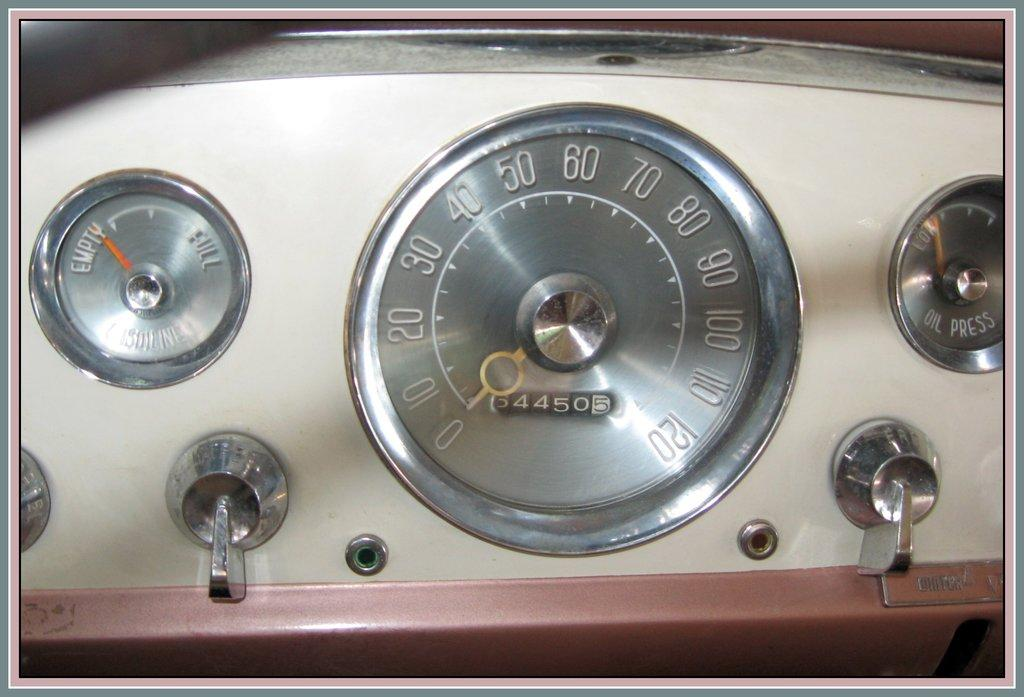What device is visible in the image? There is a speedometer in the image. What type of footwear is visible on the sofa in the image? There is no footwear or sofa present in the image; it only features a speedometer. 